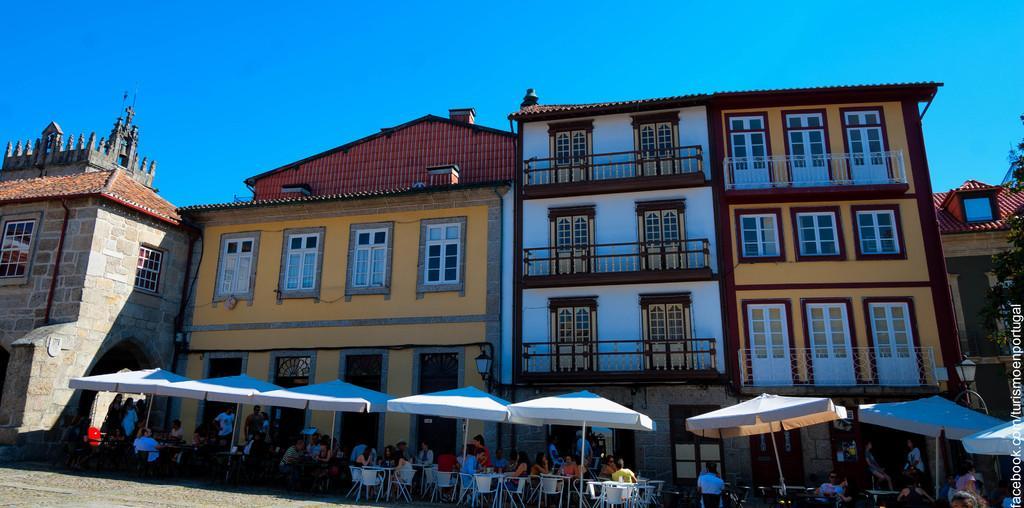Can you describe this image briefly? There is a group of persons sitting on the chairs, and some persons are standing under the umbrellas as we can see at the bottom of this image, and there are some buildings in the background. There is a blue sky at the top of this image. 